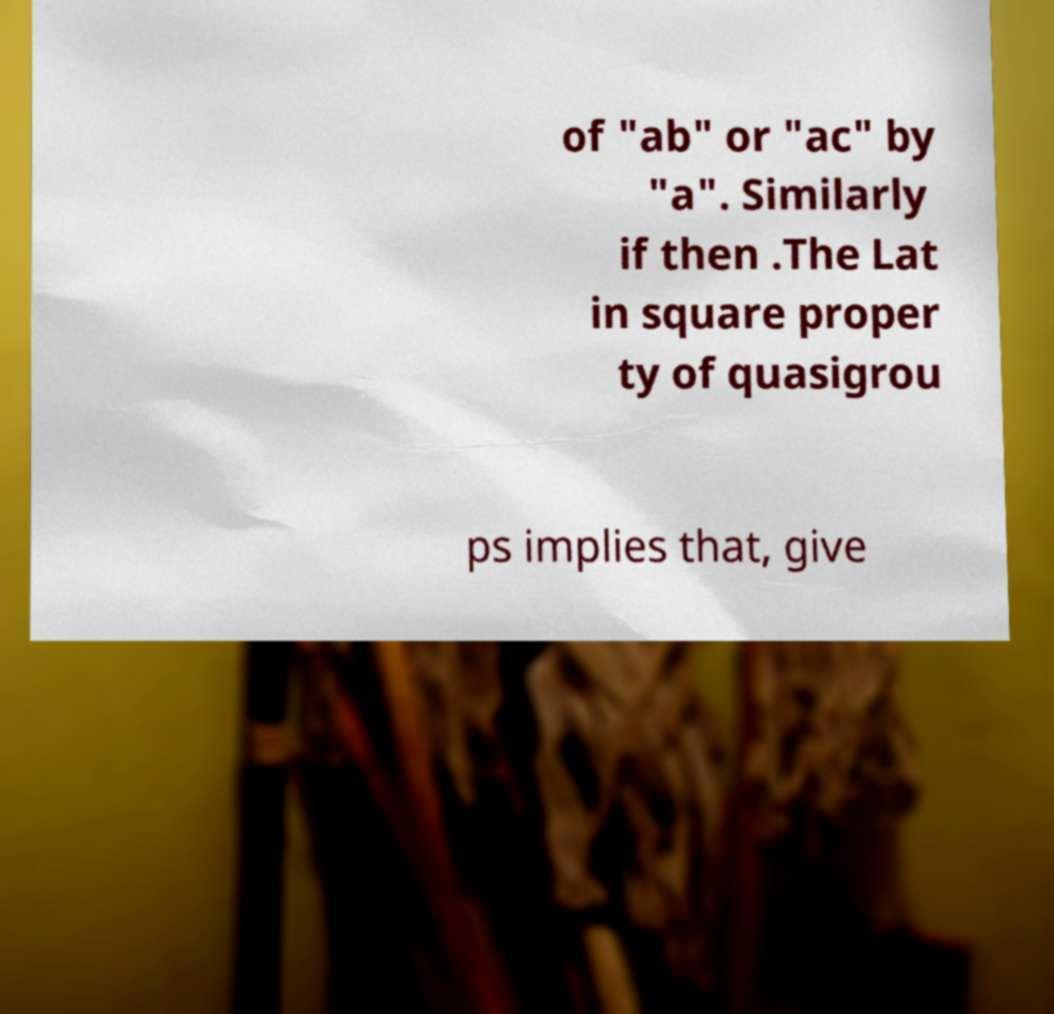There's text embedded in this image that I need extracted. Can you transcribe it verbatim? of "ab" or "ac" by "a". Similarly if then .The Lat in square proper ty of quasigrou ps implies that, give 